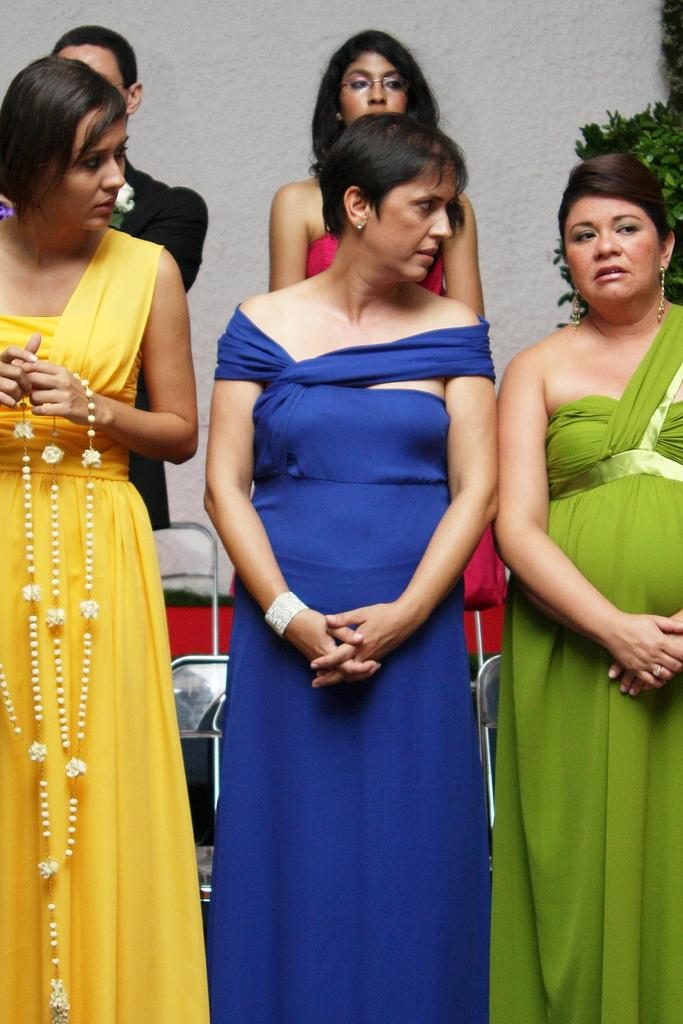Who is present in the image? There are women in the image. What is one of the women holding? One of the women is holding a garland. What type of furniture can be seen in the image? There are chairs in the image. What kind of vegetation is visible in the image? There is a plant in the image. What type of quince is being discussed by the committee in the image? There is no committee or discussion about quince in the image; it features women, a garland, chairs, and a plant. 